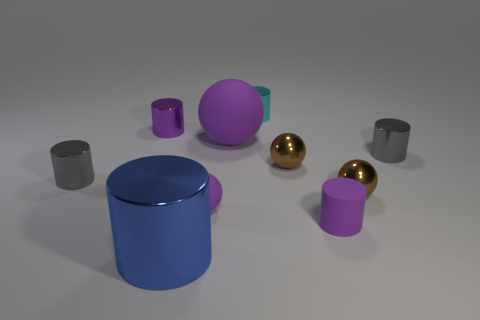Subtract 1 spheres. How many spheres are left? 3 Subtract all gray cylinders. How many cylinders are left? 4 Subtract all cyan cylinders. How many cylinders are left? 5 Subtract all purple cylinders. Subtract all brown blocks. How many cylinders are left? 4 Subtract all spheres. How many objects are left? 6 Subtract all shiny things. Subtract all purple rubber cylinders. How many objects are left? 2 Add 5 big blue cylinders. How many big blue cylinders are left? 6 Add 1 cyan matte balls. How many cyan matte balls exist? 1 Subtract 0 cyan cubes. How many objects are left? 10 